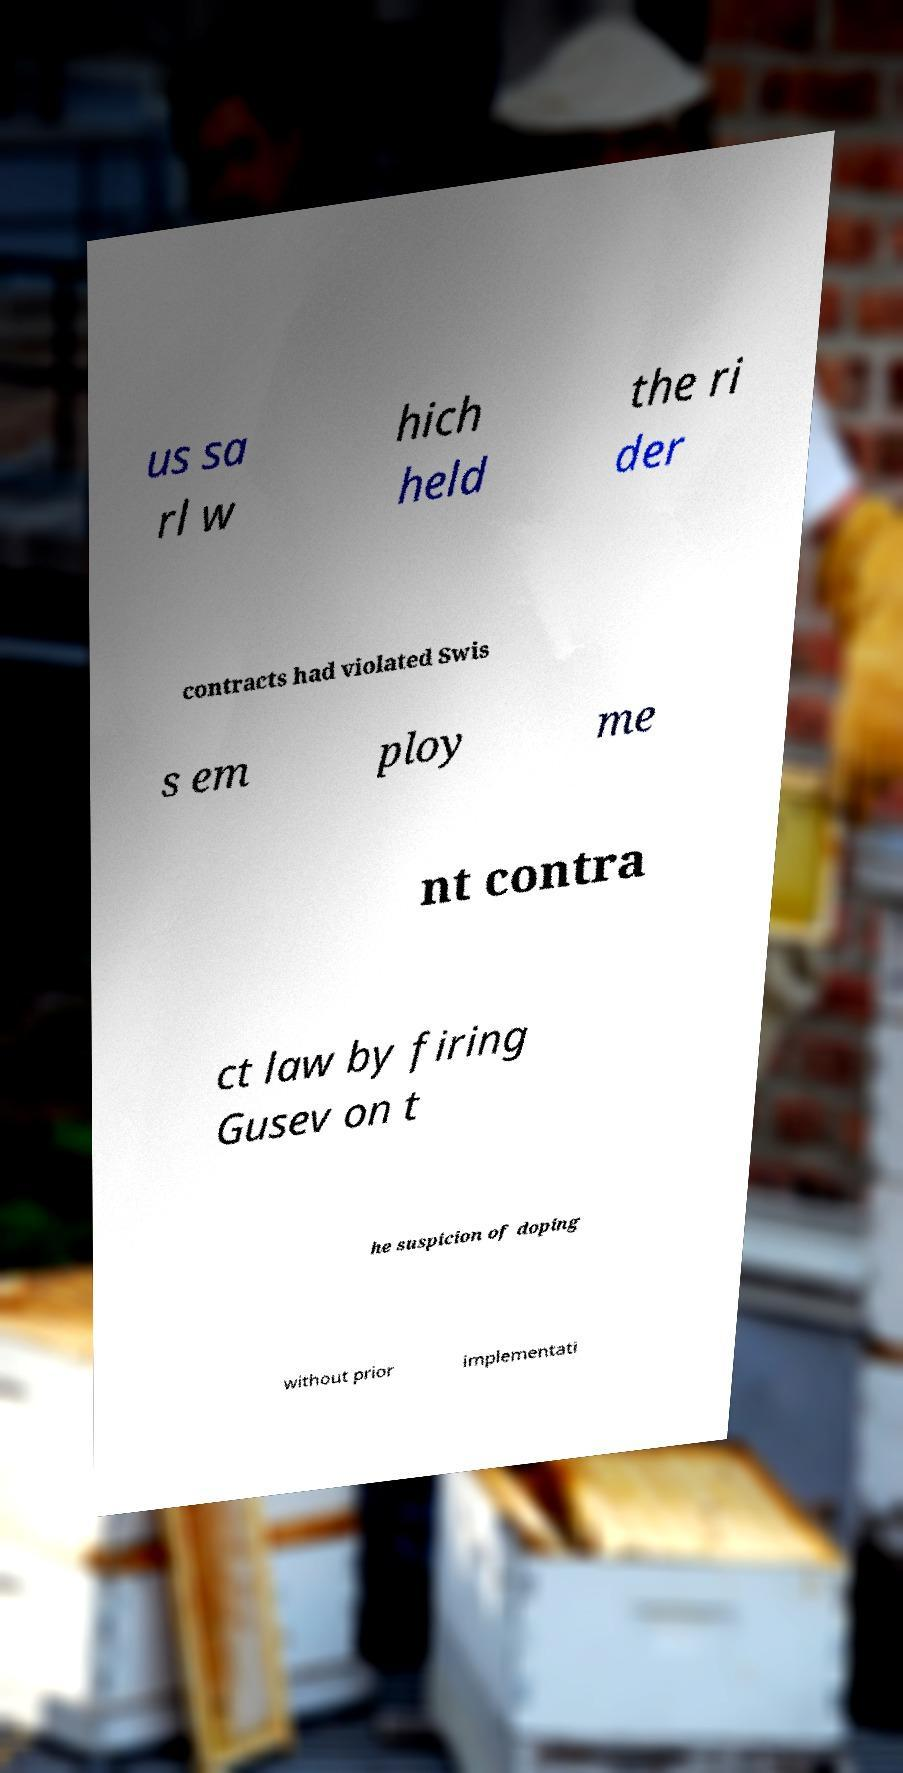Please read and relay the text visible in this image. What does it say? us sa rl w hich held the ri der contracts had violated Swis s em ploy me nt contra ct law by firing Gusev on t he suspicion of doping without prior implementati 